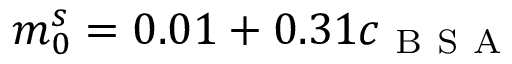<formula> <loc_0><loc_0><loc_500><loc_500>m _ { 0 } ^ { s } = 0 . 0 1 + 0 . 3 1 c _ { B S A }</formula> 